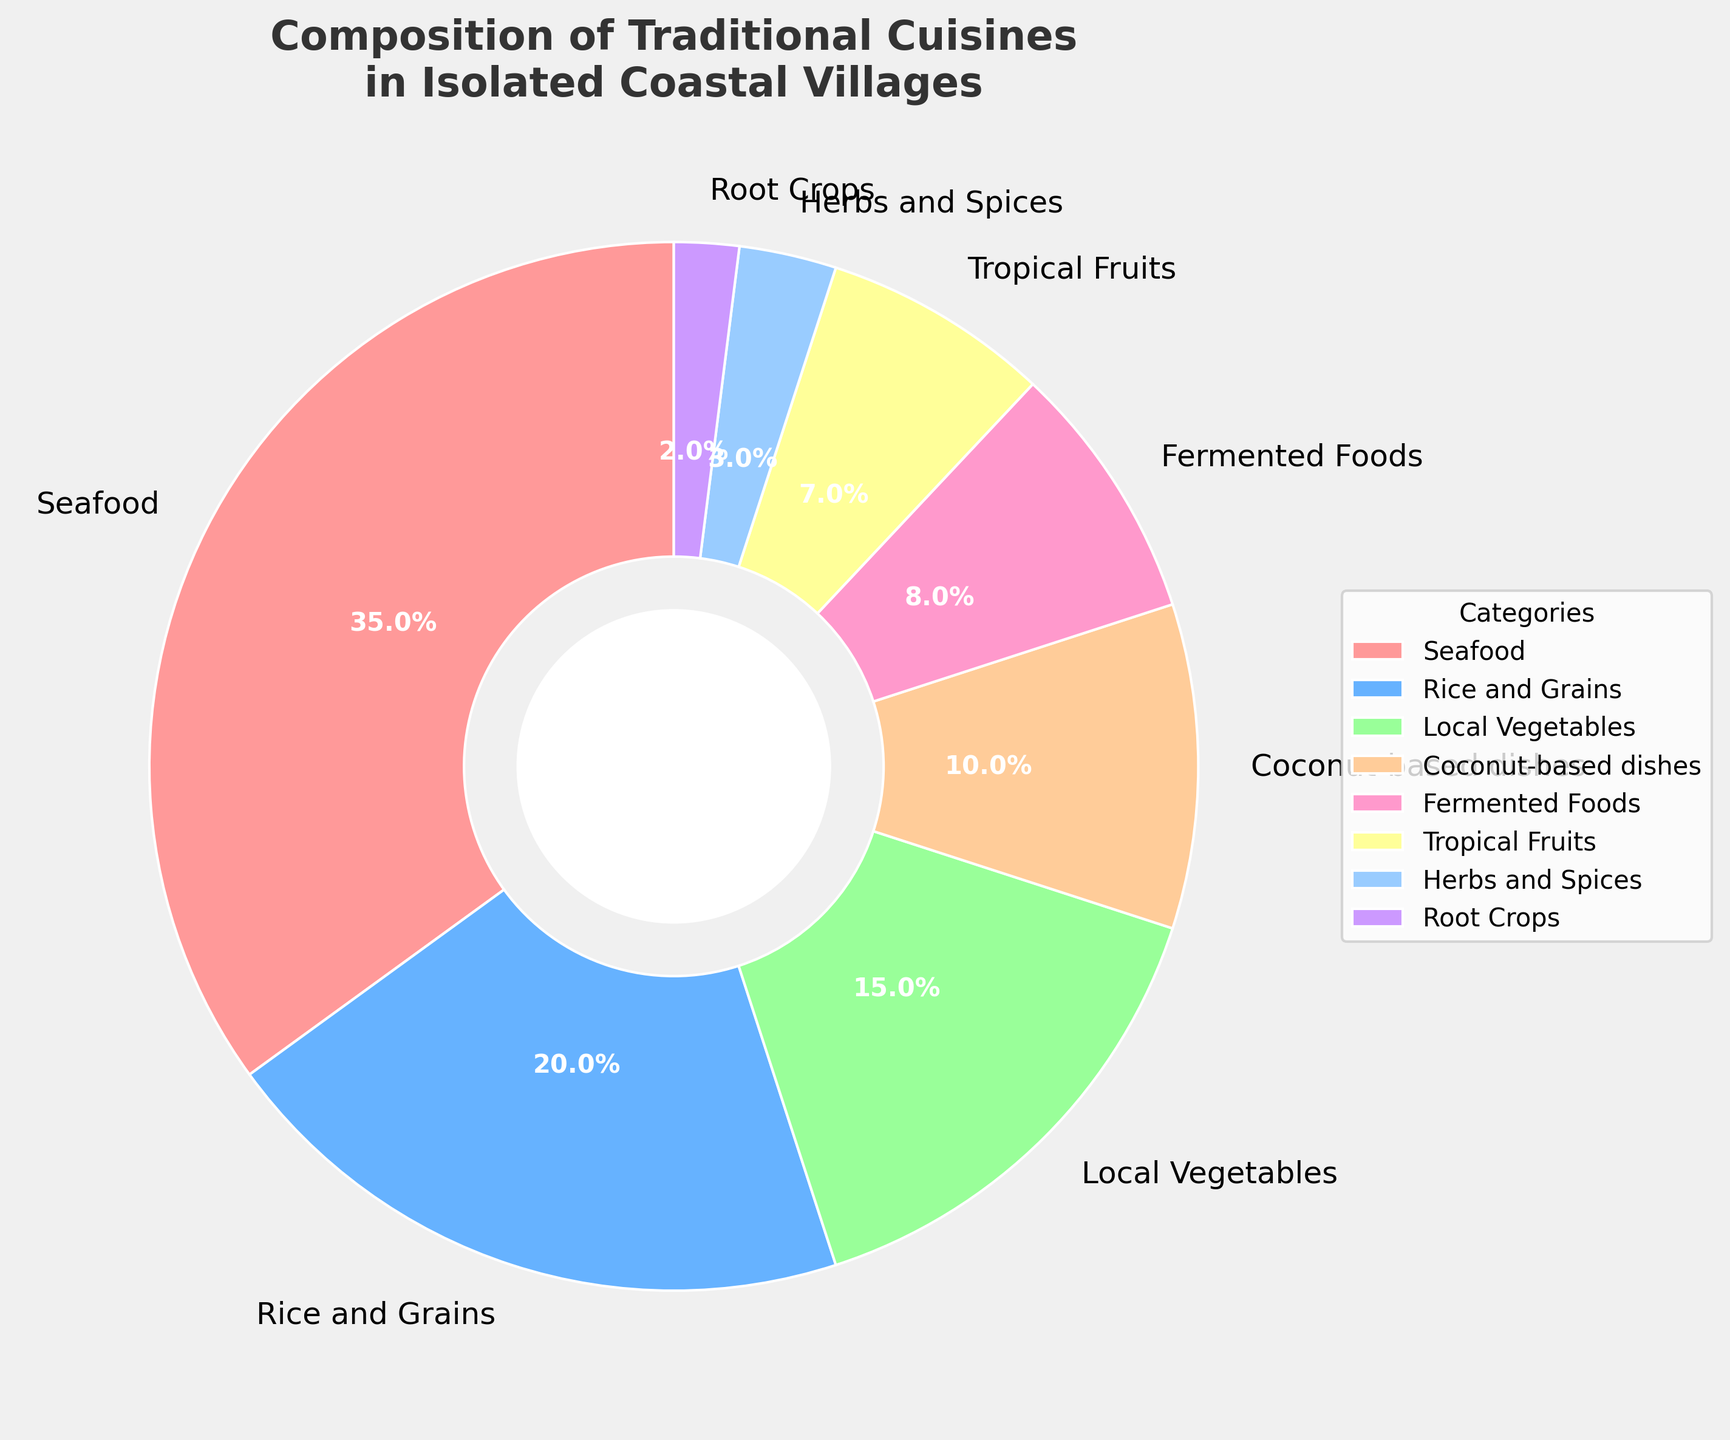what category makes up the largest proportion of traditional cuisines in isolated coastal villages? By examining the pie chart, we can see that the largest wedge corresponds to Seafood, which occupies the largest percentage segment.
Answer: Seafood How many categories make up at least 10% of the traditional cuisines? From the pie chart, we can identify wedges whose labels indicate percentages above 10%. These are Seafood (35%), Rice and Grains (20%), and Local Vegetables (15%).
Answer: 3 Which categories combined account for the majority of the traditional cuisines? To find the majority, we need more than 50%. By adding the percentages of the largest categories sequentially: Seafood (35%) + Rice and Grains (20%) = 55%. This already exceeds 50%, so the majority comprises Seafood and Rice and Grains.
Answer: Seafood and Rice and Grains What is the smallest category in the composition of traditional cuisines? By examining the pie chart, the smallest wedge corresponds to Root Crops, which has the lowest percentage slice.
Answer: Root Crops Which category has a larger proportion: Local Vegetables or Coconut-based dishes, and by how much? By looking at the pie chart, we see that Local Vegetables (15%) have a larger proportion than Coconut-based dishes (10%). The difference is 15% - 10% = 5%.
Answer: Local Vegetables by 5% If you combine the proportions of Tropical Fruits and Herbs and Spices, how do they compare to Coconut-based dishes? Tropical Fruits and Herbs and Spices together have percentages as follows: 7% (Tropical Fruits) + 3% (Herbs and Spices) = 10%. This is equal to the proportion for Coconut-based dishes (10%).
Answer: Equal Which categories are represented by less than 10% each? From the pie chart, the categories with wedges smaller than 10% are Fermented Foods, Tropical Fruits, Herbs and Spices, and Root Crops.
Answer: Fermented Foods, Tropical Fruits, Herbs and Spices, Root Crops By how much does the proportion of Seafood exceed that of Local Vegetables? Examining the pie chart, Seafood is 35% and Local Vegetables are 15%. The difference in their proportions is 35% - 15% = 20%.
Answer: 20% 